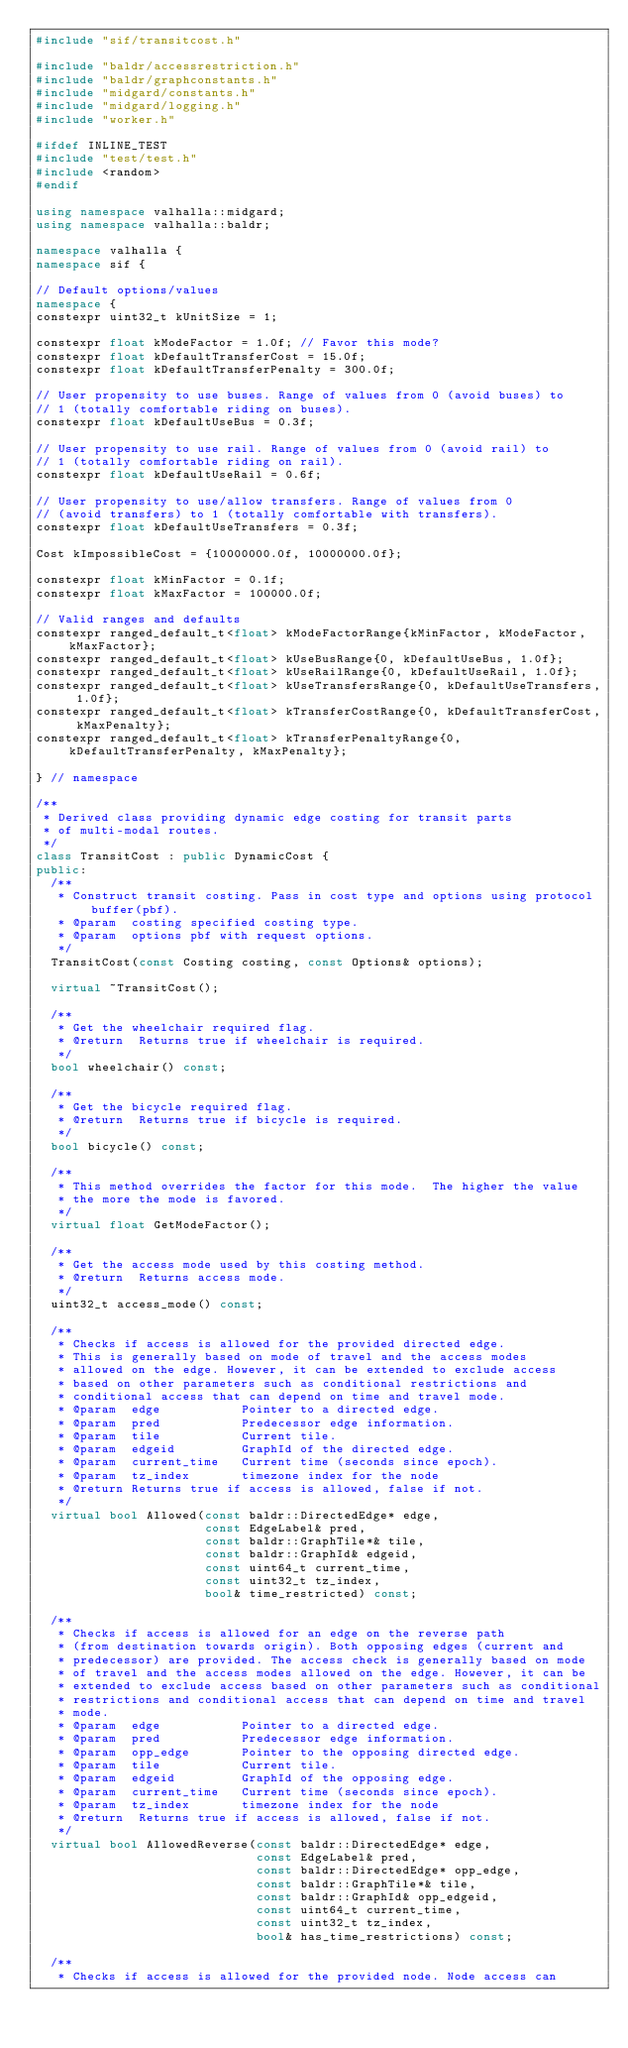Convert code to text. <code><loc_0><loc_0><loc_500><loc_500><_C++_>#include "sif/transitcost.h"

#include "baldr/accessrestriction.h"
#include "baldr/graphconstants.h"
#include "midgard/constants.h"
#include "midgard/logging.h"
#include "worker.h"

#ifdef INLINE_TEST
#include "test/test.h"
#include <random>
#endif

using namespace valhalla::midgard;
using namespace valhalla::baldr;

namespace valhalla {
namespace sif {

// Default options/values
namespace {
constexpr uint32_t kUnitSize = 1;

constexpr float kModeFactor = 1.0f; // Favor this mode?
constexpr float kDefaultTransferCost = 15.0f;
constexpr float kDefaultTransferPenalty = 300.0f;

// User propensity to use buses. Range of values from 0 (avoid buses) to
// 1 (totally comfortable riding on buses).
constexpr float kDefaultUseBus = 0.3f;

// User propensity to use rail. Range of values from 0 (avoid rail) to
// 1 (totally comfortable riding on rail).
constexpr float kDefaultUseRail = 0.6f;

// User propensity to use/allow transfers. Range of values from 0
// (avoid transfers) to 1 (totally comfortable with transfers).
constexpr float kDefaultUseTransfers = 0.3f;

Cost kImpossibleCost = {10000000.0f, 10000000.0f};

constexpr float kMinFactor = 0.1f;
constexpr float kMaxFactor = 100000.0f;

// Valid ranges and defaults
constexpr ranged_default_t<float> kModeFactorRange{kMinFactor, kModeFactor, kMaxFactor};
constexpr ranged_default_t<float> kUseBusRange{0, kDefaultUseBus, 1.0f};
constexpr ranged_default_t<float> kUseRailRange{0, kDefaultUseRail, 1.0f};
constexpr ranged_default_t<float> kUseTransfersRange{0, kDefaultUseTransfers, 1.0f};
constexpr ranged_default_t<float> kTransferCostRange{0, kDefaultTransferCost, kMaxPenalty};
constexpr ranged_default_t<float> kTransferPenaltyRange{0, kDefaultTransferPenalty, kMaxPenalty};

} // namespace

/**
 * Derived class providing dynamic edge costing for transit parts
 * of multi-modal routes.
 */
class TransitCost : public DynamicCost {
public:
  /**
   * Construct transit costing. Pass in cost type and options using protocol buffer(pbf).
   * @param  costing specified costing type.
   * @param  options pbf with request options.
   */
  TransitCost(const Costing costing, const Options& options);

  virtual ~TransitCost();

  /**
   * Get the wheelchair required flag.
   * @return  Returns true if wheelchair is required.
   */
  bool wheelchair() const;

  /**
   * Get the bicycle required flag.
   * @return  Returns true if bicycle is required.
   */
  bool bicycle() const;

  /**
   * This method overrides the factor for this mode.  The higher the value
   * the more the mode is favored.
   */
  virtual float GetModeFactor();

  /**
   * Get the access mode used by this costing method.
   * @return  Returns access mode.
   */
  uint32_t access_mode() const;

  /**
   * Checks if access is allowed for the provided directed edge.
   * This is generally based on mode of travel and the access modes
   * allowed on the edge. However, it can be extended to exclude access
   * based on other parameters such as conditional restrictions and
   * conditional access that can depend on time and travel mode.
   * @param  edge           Pointer to a directed edge.
   * @param  pred           Predecessor edge information.
   * @param  tile           Current tile.
   * @param  edgeid         GraphId of the directed edge.
   * @param  current_time   Current time (seconds since epoch).
   * @param  tz_index       timezone index for the node
   * @return Returns true if access is allowed, false if not.
   */
  virtual bool Allowed(const baldr::DirectedEdge* edge,
                       const EdgeLabel& pred,
                       const baldr::GraphTile*& tile,
                       const baldr::GraphId& edgeid,
                       const uint64_t current_time,
                       const uint32_t tz_index,
                       bool& time_restricted) const;

  /**
   * Checks if access is allowed for an edge on the reverse path
   * (from destination towards origin). Both opposing edges (current and
   * predecessor) are provided. The access check is generally based on mode
   * of travel and the access modes allowed on the edge. However, it can be
   * extended to exclude access based on other parameters such as conditional
   * restrictions and conditional access that can depend on time and travel
   * mode.
   * @param  edge           Pointer to a directed edge.
   * @param  pred           Predecessor edge information.
   * @param  opp_edge       Pointer to the opposing directed edge.
   * @param  tile           Current tile.
   * @param  edgeid         GraphId of the opposing edge.
   * @param  current_time   Current time (seconds since epoch).
   * @param  tz_index       timezone index for the node
   * @return  Returns true if access is allowed, false if not.
   */
  virtual bool AllowedReverse(const baldr::DirectedEdge* edge,
                              const EdgeLabel& pred,
                              const baldr::DirectedEdge* opp_edge,
                              const baldr::GraphTile*& tile,
                              const baldr::GraphId& opp_edgeid,
                              const uint64_t current_time,
                              const uint32_t tz_index,
                              bool& has_time_restrictions) const;

  /**
   * Checks if access is allowed for the provided node. Node access can</code> 